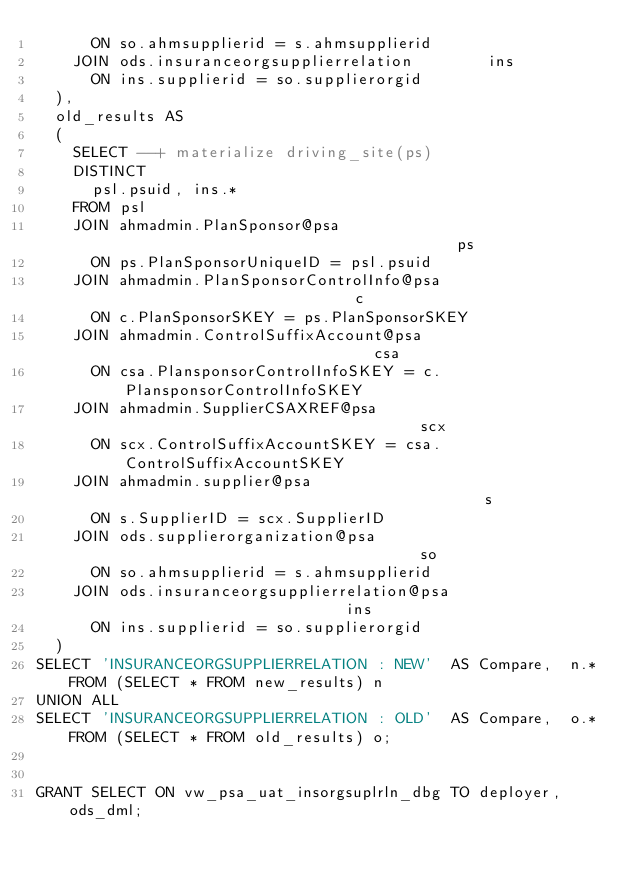Convert code to text. <code><loc_0><loc_0><loc_500><loc_500><_SQL_>      ON so.ahmsupplierid = s.ahmsupplierid    
    JOIN ods.insuranceorgsupplierrelation        ins
      ON ins.supplierid = so.supplierorgid
  ),     
  old_results AS
  (
    SELECT --+ materialize driving_site(ps)
    DISTINCT   
      psl.psuid, ins.*
    FROM psl                                                            
    JOIN ahmadmin.PlanSponsor@psa                                       ps
      ON ps.PlanSponsorUniqueID = psl.psuid
    JOIN ahmadmin.PlanSponsorControlInfo@psa                            c
      ON c.PlanSponsorSKEY = ps.PlanSponsorSKEY
    JOIN ahmadmin.ControlSuffixAccount@psa                              csa
      ON csa.PlansponsorControlInfoSKEY = c.PlansponsorControlInfoSKEY
    JOIN ahmadmin.SupplierCSAXREF@psa                                   scx
      ON scx.ControlSuffixAccountSKEY = csa.ControlSuffixAccountSKEY
    JOIN ahmadmin.supplier@psa                                          s
      ON s.SupplierID = scx.SupplierID 
    JOIN ods.supplierorganization@psa                                   so
      ON so.ahmsupplierid = s.ahmsupplierid                             
    JOIN ods.insuranceorgsupplierrelation@psa                           ins
      ON ins.supplierid = so.supplierorgid
  )
SELECT 'INSURANCEORGSUPPLIERRELATION : NEW'  AS Compare,  n.* FROM (SELECT * FROM new_results) n
UNION ALL
SELECT 'INSURANCEORGSUPPLIERRELATION : OLD'  AS Compare,  o.* FROM (SELECT * FROM old_results) o;


GRANT SELECT ON vw_psa_uat_insorgsuplrln_dbg TO deployer, ods_dml;</code> 